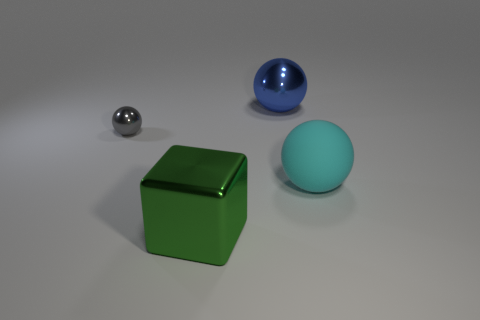What number of shiny things are either small brown cylinders or spheres?
Give a very brief answer. 2. Are there the same number of large blue metallic balls that are right of the rubber sphere and big purple shiny cylinders?
Provide a succinct answer. Yes. Do the metal sphere that is on the right side of the small shiny object and the small object have the same color?
Offer a very short reply. No. The object that is to the right of the tiny metal object and on the left side of the blue object is made of what material?
Keep it short and to the point. Metal. There is a thing in front of the big rubber ball; are there any large green things left of it?
Offer a very short reply. No. Is the material of the large blue ball the same as the big cyan ball?
Provide a succinct answer. No. What is the shape of the large object that is both left of the cyan object and in front of the gray metallic sphere?
Your answer should be compact. Cube. There is a thing that is in front of the sphere in front of the tiny metallic object; how big is it?
Offer a terse response. Large. How many small purple rubber objects are the same shape as the big cyan object?
Keep it short and to the point. 0. Do the large metal ball and the matte ball have the same color?
Provide a succinct answer. No. 